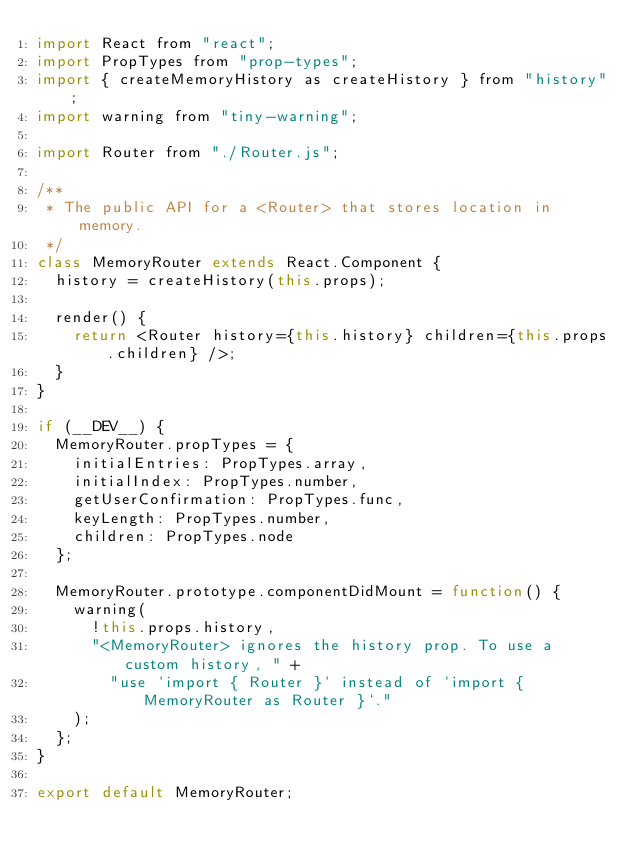Convert code to text. <code><loc_0><loc_0><loc_500><loc_500><_JavaScript_>import React from "react";
import PropTypes from "prop-types";
import { createMemoryHistory as createHistory } from "history";
import warning from "tiny-warning";

import Router from "./Router.js";

/**
 * The public API for a <Router> that stores location in memory.
 */
class MemoryRouter extends React.Component {
  history = createHistory(this.props);

  render() {
    return <Router history={this.history} children={this.props.children} />;
  }
}

if (__DEV__) {
  MemoryRouter.propTypes = {
    initialEntries: PropTypes.array,
    initialIndex: PropTypes.number,
    getUserConfirmation: PropTypes.func,
    keyLength: PropTypes.number,
    children: PropTypes.node
  };

  MemoryRouter.prototype.componentDidMount = function() {
    warning(
      !this.props.history,
      "<MemoryRouter> ignores the history prop. To use a custom history, " +
        "use `import { Router }` instead of `import { MemoryRouter as Router }`."
    );
  };
}

export default MemoryRouter;
</code> 